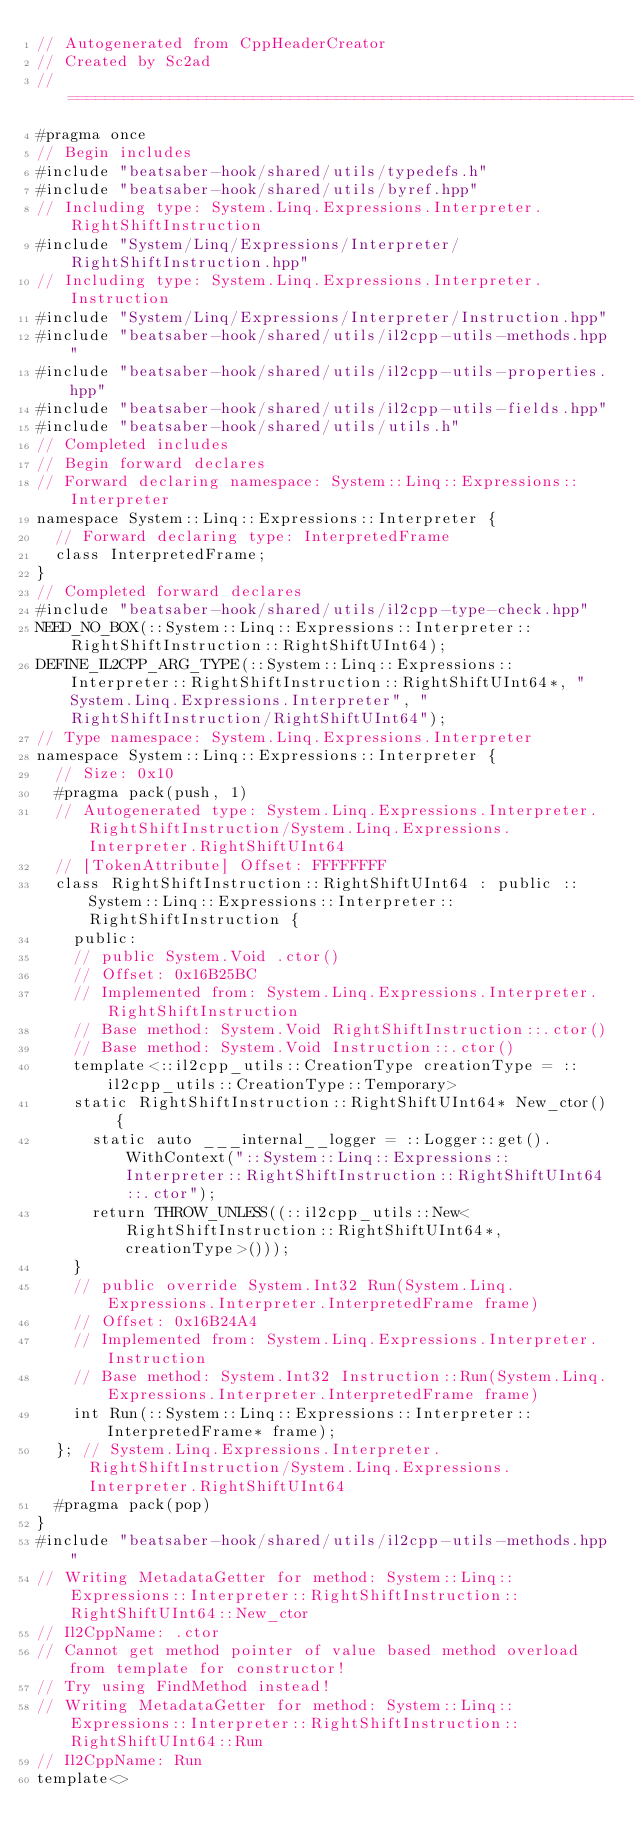Convert code to text. <code><loc_0><loc_0><loc_500><loc_500><_C++_>// Autogenerated from CppHeaderCreator
// Created by Sc2ad
// =========================================================================
#pragma once
// Begin includes
#include "beatsaber-hook/shared/utils/typedefs.h"
#include "beatsaber-hook/shared/utils/byref.hpp"
// Including type: System.Linq.Expressions.Interpreter.RightShiftInstruction
#include "System/Linq/Expressions/Interpreter/RightShiftInstruction.hpp"
// Including type: System.Linq.Expressions.Interpreter.Instruction
#include "System/Linq/Expressions/Interpreter/Instruction.hpp"
#include "beatsaber-hook/shared/utils/il2cpp-utils-methods.hpp"
#include "beatsaber-hook/shared/utils/il2cpp-utils-properties.hpp"
#include "beatsaber-hook/shared/utils/il2cpp-utils-fields.hpp"
#include "beatsaber-hook/shared/utils/utils.h"
// Completed includes
// Begin forward declares
// Forward declaring namespace: System::Linq::Expressions::Interpreter
namespace System::Linq::Expressions::Interpreter {
  // Forward declaring type: InterpretedFrame
  class InterpretedFrame;
}
// Completed forward declares
#include "beatsaber-hook/shared/utils/il2cpp-type-check.hpp"
NEED_NO_BOX(::System::Linq::Expressions::Interpreter::RightShiftInstruction::RightShiftUInt64);
DEFINE_IL2CPP_ARG_TYPE(::System::Linq::Expressions::Interpreter::RightShiftInstruction::RightShiftUInt64*, "System.Linq.Expressions.Interpreter", "RightShiftInstruction/RightShiftUInt64");
// Type namespace: System.Linq.Expressions.Interpreter
namespace System::Linq::Expressions::Interpreter {
  // Size: 0x10
  #pragma pack(push, 1)
  // Autogenerated type: System.Linq.Expressions.Interpreter.RightShiftInstruction/System.Linq.Expressions.Interpreter.RightShiftUInt64
  // [TokenAttribute] Offset: FFFFFFFF
  class RightShiftInstruction::RightShiftUInt64 : public ::System::Linq::Expressions::Interpreter::RightShiftInstruction {
    public:
    // public System.Void .ctor()
    // Offset: 0x16B25BC
    // Implemented from: System.Linq.Expressions.Interpreter.RightShiftInstruction
    // Base method: System.Void RightShiftInstruction::.ctor()
    // Base method: System.Void Instruction::.ctor()
    template<::il2cpp_utils::CreationType creationType = ::il2cpp_utils::CreationType::Temporary>
    static RightShiftInstruction::RightShiftUInt64* New_ctor() {
      static auto ___internal__logger = ::Logger::get().WithContext("::System::Linq::Expressions::Interpreter::RightShiftInstruction::RightShiftUInt64::.ctor");
      return THROW_UNLESS((::il2cpp_utils::New<RightShiftInstruction::RightShiftUInt64*, creationType>()));
    }
    // public override System.Int32 Run(System.Linq.Expressions.Interpreter.InterpretedFrame frame)
    // Offset: 0x16B24A4
    // Implemented from: System.Linq.Expressions.Interpreter.Instruction
    // Base method: System.Int32 Instruction::Run(System.Linq.Expressions.Interpreter.InterpretedFrame frame)
    int Run(::System::Linq::Expressions::Interpreter::InterpretedFrame* frame);
  }; // System.Linq.Expressions.Interpreter.RightShiftInstruction/System.Linq.Expressions.Interpreter.RightShiftUInt64
  #pragma pack(pop)
}
#include "beatsaber-hook/shared/utils/il2cpp-utils-methods.hpp"
// Writing MetadataGetter for method: System::Linq::Expressions::Interpreter::RightShiftInstruction::RightShiftUInt64::New_ctor
// Il2CppName: .ctor
// Cannot get method pointer of value based method overload from template for constructor!
// Try using FindMethod instead!
// Writing MetadataGetter for method: System::Linq::Expressions::Interpreter::RightShiftInstruction::RightShiftUInt64::Run
// Il2CppName: Run
template<></code> 